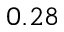Convert formula to latex. <formula><loc_0><loc_0><loc_500><loc_500>0 . 2 8</formula> 